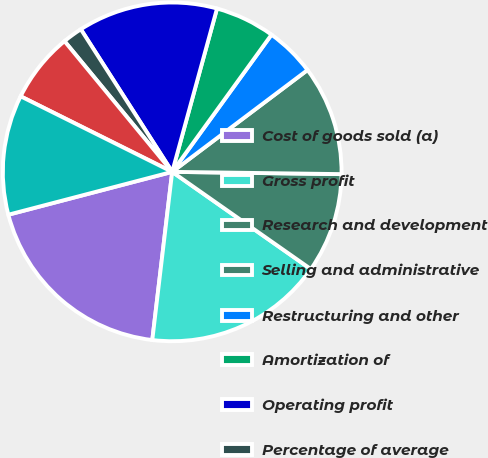<chart> <loc_0><loc_0><loc_500><loc_500><pie_chart><fcel>Cost of goods sold (a)<fcel>Gross profit<fcel>Research and development<fcel>Selling and administrative<fcel>Restructuring and other<fcel>Amortization of<fcel>Operating profit<fcel>Percentage of average<fcel>Average number of diluted<fcel>Receivables net<nl><fcel>19.05%<fcel>17.14%<fcel>9.52%<fcel>10.48%<fcel>4.76%<fcel>5.71%<fcel>13.33%<fcel>1.9%<fcel>6.67%<fcel>11.43%<nl></chart> 